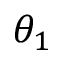Convert formula to latex. <formula><loc_0><loc_0><loc_500><loc_500>\theta _ { 1 }</formula> 